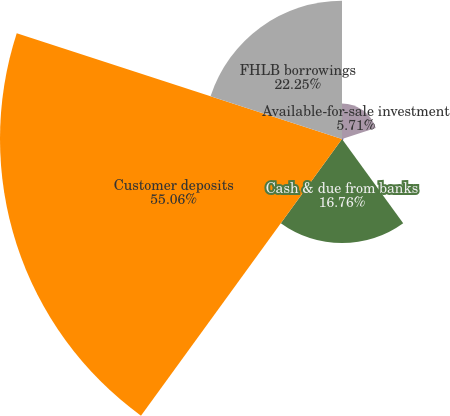Convert chart. <chart><loc_0><loc_0><loc_500><loc_500><pie_chart><fcel>Available-for-sale investment<fcel>Federal funds sold<fcel>Cash & due from banks<fcel>Customer deposits<fcel>FHLB borrowings<nl><fcel>5.71%<fcel>0.22%<fcel>16.76%<fcel>55.06%<fcel>22.25%<nl></chart> 